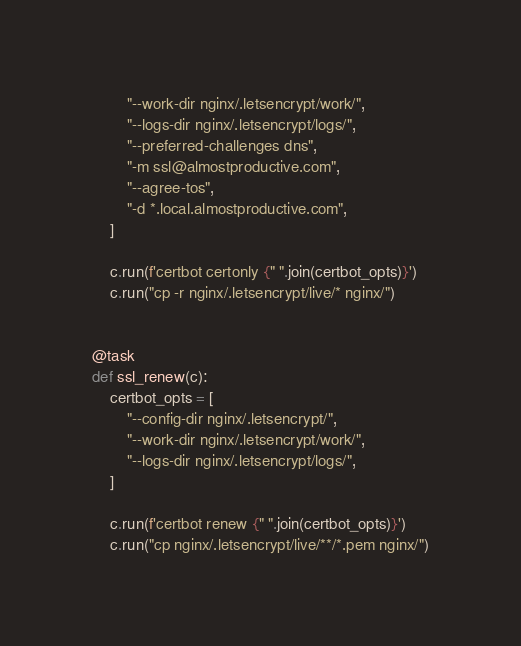<code> <loc_0><loc_0><loc_500><loc_500><_Python_>        "--work-dir nginx/.letsencrypt/work/",
        "--logs-dir nginx/.letsencrypt/logs/",
        "--preferred-challenges dns",
        "-m ssl@almostproductive.com",
        "--agree-tos",
        "-d *.local.almostproductive.com",
    ]

    c.run(f'certbot certonly {" ".join(certbot_opts)}')
    c.run("cp -r nginx/.letsencrypt/live/* nginx/")


@task
def ssl_renew(c):
    certbot_opts = [
        "--config-dir nginx/.letsencrypt/",
        "--work-dir nginx/.letsencrypt/work/",
        "--logs-dir nginx/.letsencrypt/logs/",
    ]

    c.run(f'certbot renew {" ".join(certbot_opts)}')
    c.run("cp nginx/.letsencrypt/live/**/*.pem nginx/")
</code> 